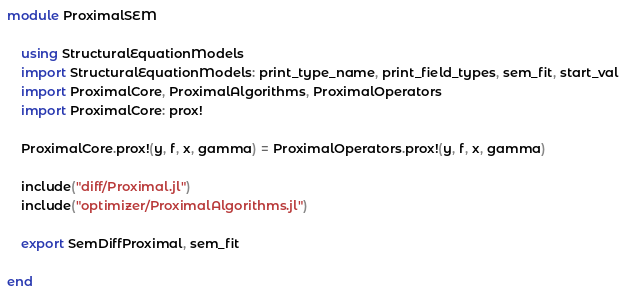Convert code to text. <code><loc_0><loc_0><loc_500><loc_500><_Julia_>module ProximalSEM

    using StructuralEquationModels
    import StructuralEquationModels: print_type_name, print_field_types, sem_fit, start_val
    import ProximalCore, ProximalAlgorithms, ProximalOperators
    import ProximalCore: prox!

    ProximalCore.prox!(y, f, x, gamma) = ProximalOperators.prox!(y, f, x, gamma)

    include("diff/Proximal.jl")
    include("optimizer/ProximalAlgorithms.jl")

    export SemDiffProximal, sem_fit

end</code> 